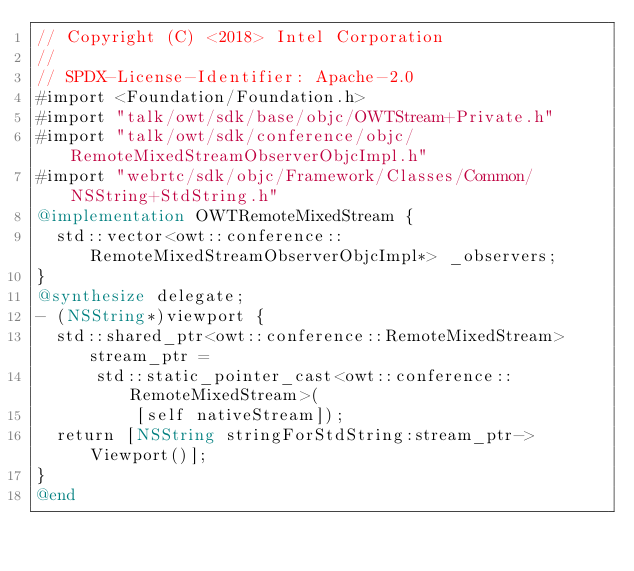<code> <loc_0><loc_0><loc_500><loc_500><_ObjectiveC_>// Copyright (C) <2018> Intel Corporation
//
// SPDX-License-Identifier: Apache-2.0
#import <Foundation/Foundation.h>
#import "talk/owt/sdk/base/objc/OWTStream+Private.h"
#import "talk/owt/sdk/conference/objc/RemoteMixedStreamObserverObjcImpl.h"
#import "webrtc/sdk/objc/Framework/Classes/Common/NSString+StdString.h"
@implementation OWTRemoteMixedStream {
  std::vector<owt::conference::RemoteMixedStreamObserverObjcImpl*> _observers;
}
@synthesize delegate;
- (NSString*)viewport {
  std::shared_ptr<owt::conference::RemoteMixedStream> stream_ptr =
      std::static_pointer_cast<owt::conference::RemoteMixedStream>(
          [self nativeStream]);
  return [NSString stringForStdString:stream_ptr->Viewport()];
}
@end
</code> 